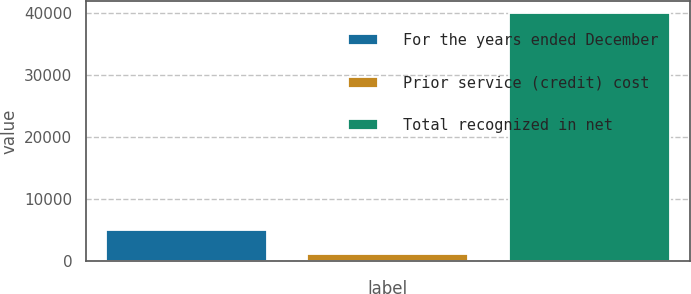Convert chart to OTSL. <chart><loc_0><loc_0><loc_500><loc_500><bar_chart><fcel>For the years ended December<fcel>Prior service (credit) cost<fcel>Total recognized in net<nl><fcel>4973.8<fcel>1086<fcel>39964<nl></chart> 